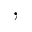Convert formula to latex. <formula><loc_0><loc_0><loc_500><loc_500>,</formula> 